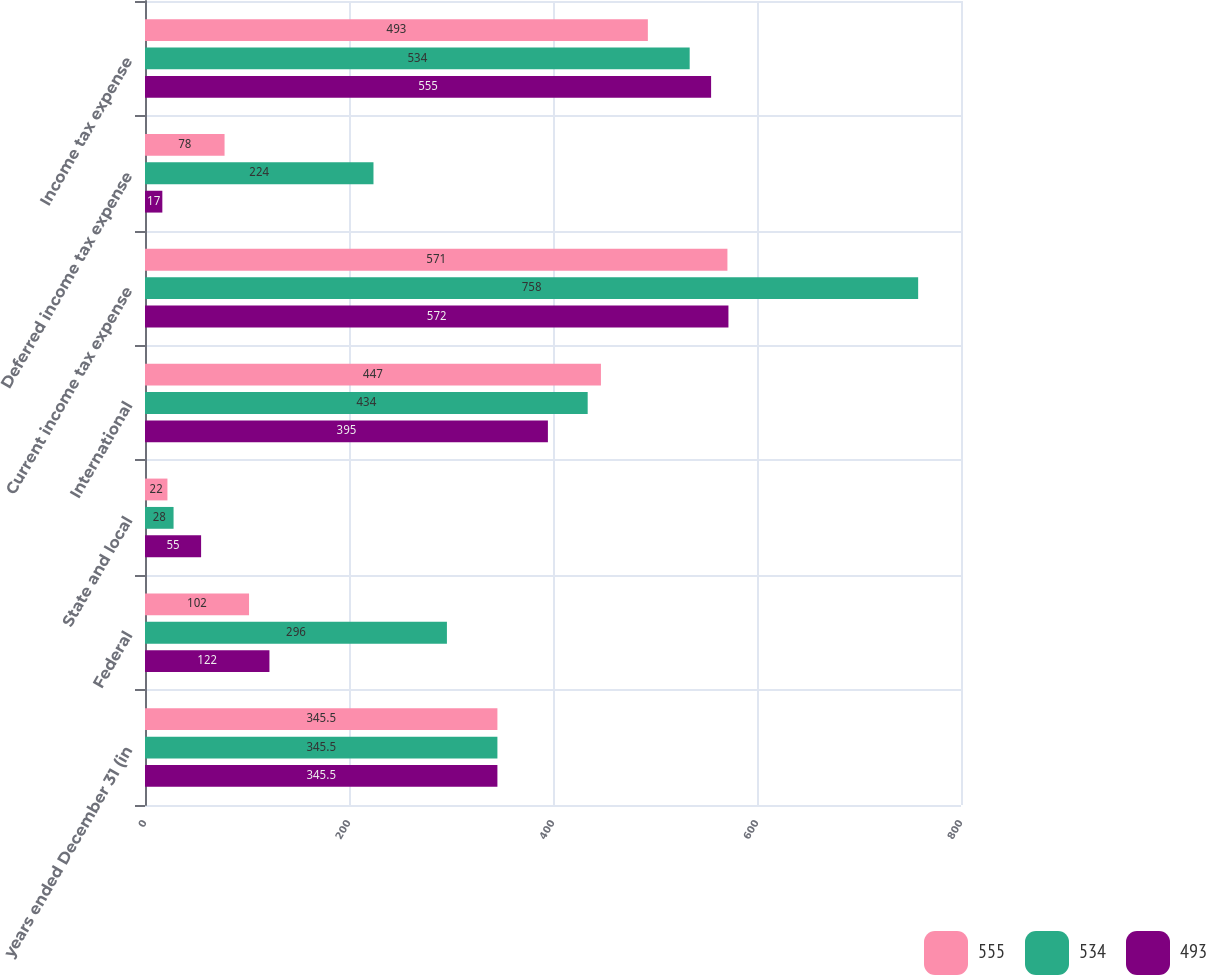Convert chart to OTSL. <chart><loc_0><loc_0><loc_500><loc_500><stacked_bar_chart><ecel><fcel>years ended December 31 (in<fcel>Federal<fcel>State and local<fcel>International<fcel>Current income tax expense<fcel>Deferred income tax expense<fcel>Income tax expense<nl><fcel>555<fcel>345.5<fcel>102<fcel>22<fcel>447<fcel>571<fcel>78<fcel>493<nl><fcel>534<fcel>345.5<fcel>296<fcel>28<fcel>434<fcel>758<fcel>224<fcel>534<nl><fcel>493<fcel>345.5<fcel>122<fcel>55<fcel>395<fcel>572<fcel>17<fcel>555<nl></chart> 